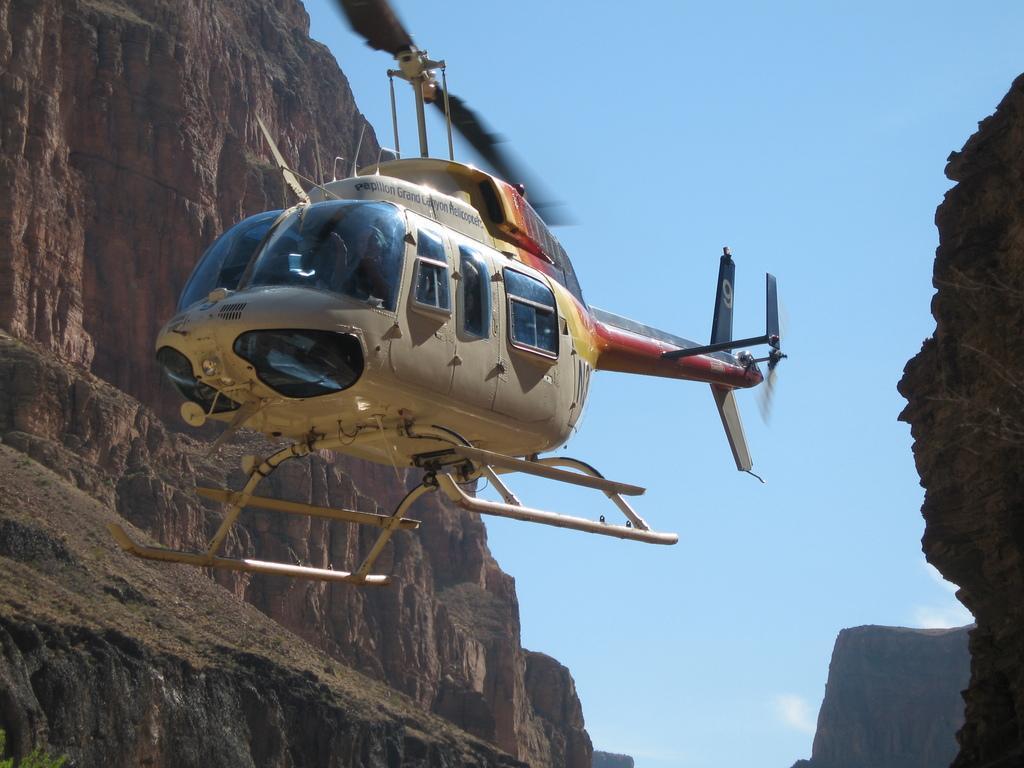How would you summarize this image in a sentence or two? In the center of the image there is a helicopter in the air. On both right and left side of the image there are rocks. In the background of the image there is sky. 